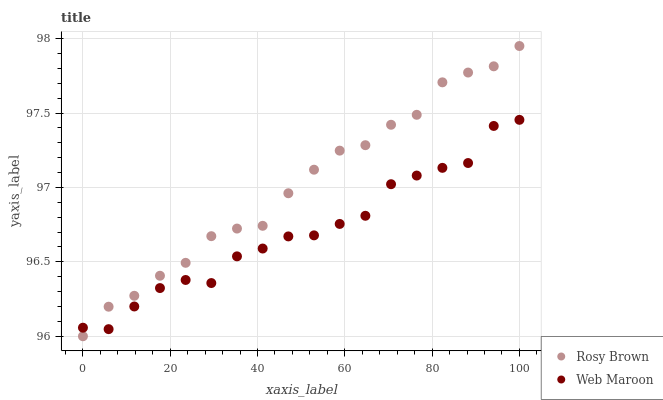Does Web Maroon have the minimum area under the curve?
Answer yes or no. Yes. Does Rosy Brown have the maximum area under the curve?
Answer yes or no. Yes. Does Web Maroon have the maximum area under the curve?
Answer yes or no. No. Is Rosy Brown the smoothest?
Answer yes or no. Yes. Is Web Maroon the roughest?
Answer yes or no. Yes. Is Web Maroon the smoothest?
Answer yes or no. No. Does Rosy Brown have the lowest value?
Answer yes or no. Yes. Does Web Maroon have the lowest value?
Answer yes or no. No. Does Rosy Brown have the highest value?
Answer yes or no. Yes. Does Web Maroon have the highest value?
Answer yes or no. No. Does Web Maroon intersect Rosy Brown?
Answer yes or no. Yes. Is Web Maroon less than Rosy Brown?
Answer yes or no. No. Is Web Maroon greater than Rosy Brown?
Answer yes or no. No. 